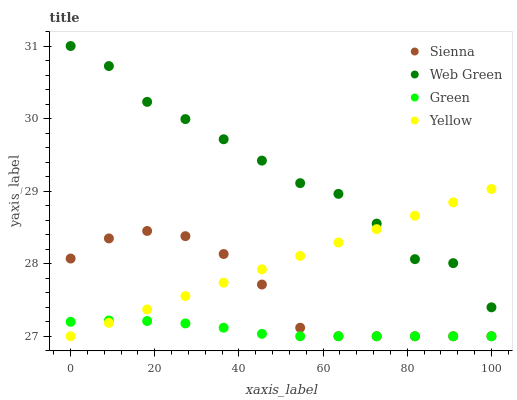Does Green have the minimum area under the curve?
Answer yes or no. Yes. Does Web Green have the maximum area under the curve?
Answer yes or no. Yes. Does Yellow have the minimum area under the curve?
Answer yes or no. No. Does Yellow have the maximum area under the curve?
Answer yes or no. No. Is Yellow the smoothest?
Answer yes or no. Yes. Is Web Green the roughest?
Answer yes or no. Yes. Is Green the smoothest?
Answer yes or no. No. Is Green the roughest?
Answer yes or no. No. Does Sienna have the lowest value?
Answer yes or no. Yes. Does Web Green have the lowest value?
Answer yes or no. No. Does Web Green have the highest value?
Answer yes or no. Yes. Does Yellow have the highest value?
Answer yes or no. No. Is Sienna less than Web Green?
Answer yes or no. Yes. Is Web Green greater than Green?
Answer yes or no. Yes. Does Green intersect Yellow?
Answer yes or no. Yes. Is Green less than Yellow?
Answer yes or no. No. Is Green greater than Yellow?
Answer yes or no. No. Does Sienna intersect Web Green?
Answer yes or no. No. 